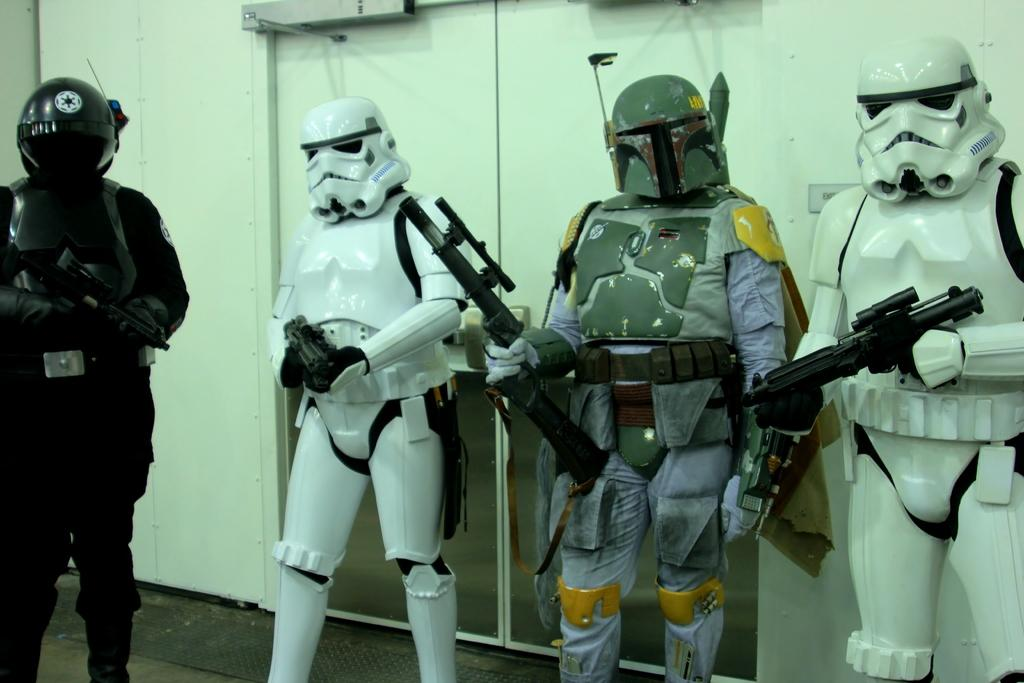What type of characters are present in the image? There are robots in the image. What are the robots holding in their hands? The robots are holding weapons. Can you describe the grey object visible at the top of the image? Unfortunately, the provided facts do not give any information about the grey object, so it cannot be described. How many stars can be seen in the image? There is no mention of stars in the provided facts, so it cannot be determined how many stars are present in the image. 